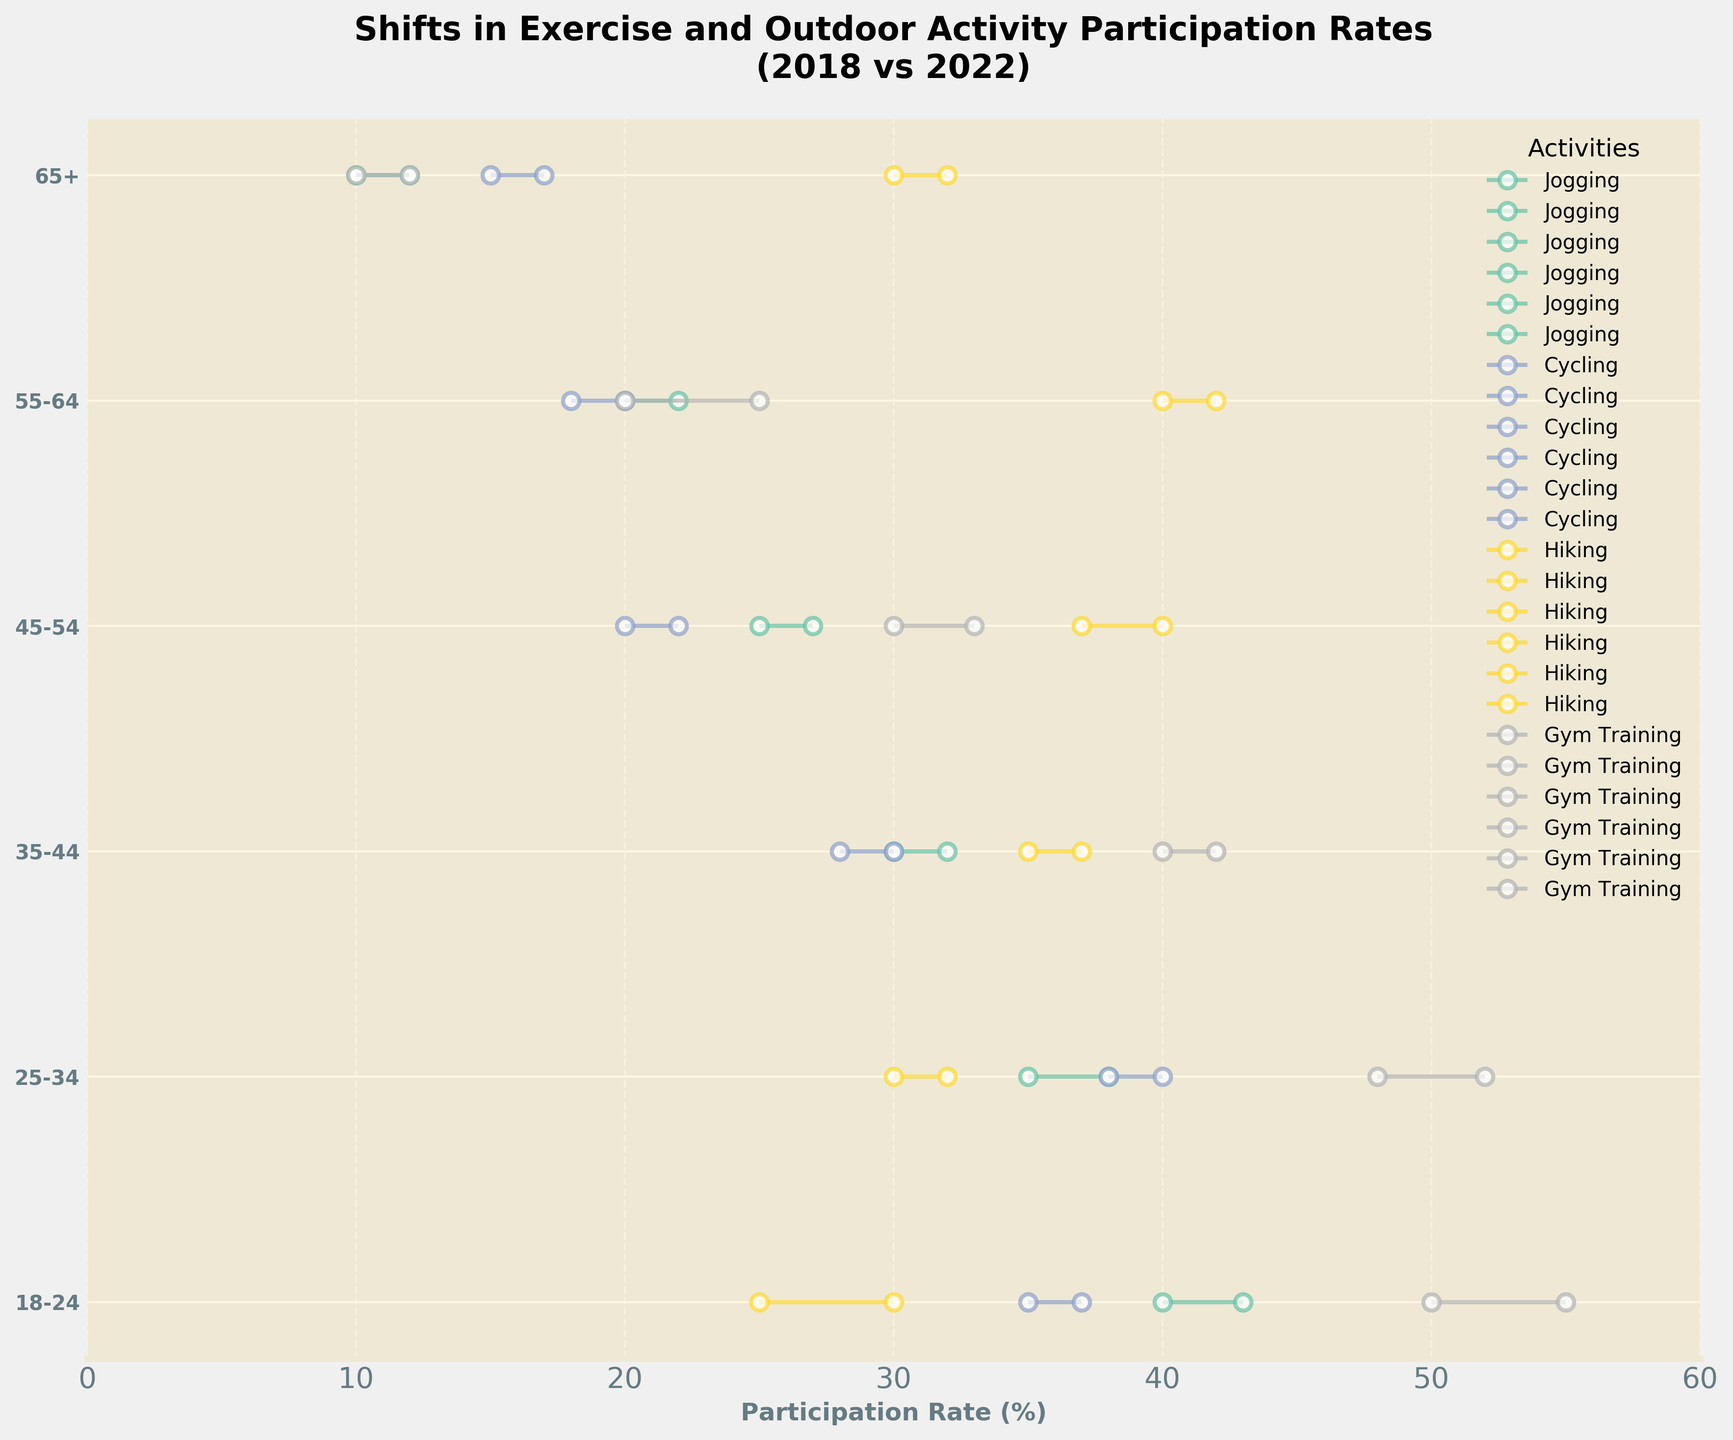Which age group had the highest participation rate in Gym Training in 2022? Look at the Gym Training line and identify which age group has the highest value at the end point of the dumbbell plot. The rate for 18-24 age group is 55%, which is the highest.
Answer: 18-24 How much did Hiking participation increase for the 45-54 age group from 2018 to 2022? Locate the 45-54 age group and trace the Hiking participation rate from 2018 to 2022. It shows an increase from 37% to 40%, resulting in a 3% increase.
Answer: 3% Which activity had the largest increase in participation rate for the 55-64 age group? Observe the lines corresponding to the 55-64 age group and compare the changes in participation rates for different activities. Gym Training increased from 20% to 25%, which is a 5% increase, the largest among that age group.
Answer: Gym Training Did any age group show a decrease in participation rate for any activity between 2018 and 2022? Review all dumbbell lines to see if any line trends downwards from 2018 to 2022. No lines show a decrease.
Answer: No What was the participation rate for Cycling in the 65+ age group in 2018? Find the Cycling category and trace it to the 65+ age group. The rate for 2018 is 15%.
Answer: 15% Which age group shows a participation rate of 10% for Gym Training in 2018? Locate Gym Training and find the age group with a 10% participation rate in 2018. The 65+ age group matches this.
Answer: 65+ Which activity had the smallest change in participation rate for the 35-44 age group? Look at the differences in the starting and ending points of each activity for the 35-44 age group. Jogging, Cycling, Hiking, and Gym Training all show a 2% increase, indicating the smallest change.
Answer: Jogging, Cycling, Hiking, Gym Training On average, which activity had the highest participation rate across all age groups in 2022? Calculate the average 2022 participation rate for each activity by summing up the 2022 participation rates and dividing by the number of age groups. Gym Training averages to (55+52+42+33+25+12)/6 = 36.5%, which is the highest.
Answer: Gym Training Which age group showed the smallest change in participation rate for all activities combined? Calculate the absolute differences in participation rates for each activity within each age group, then sum them. Compare the totals to find the smallest change. The 35-44 age group has (2+2+2+2)=8%, the smallest combined change.
Answer: 35-44 